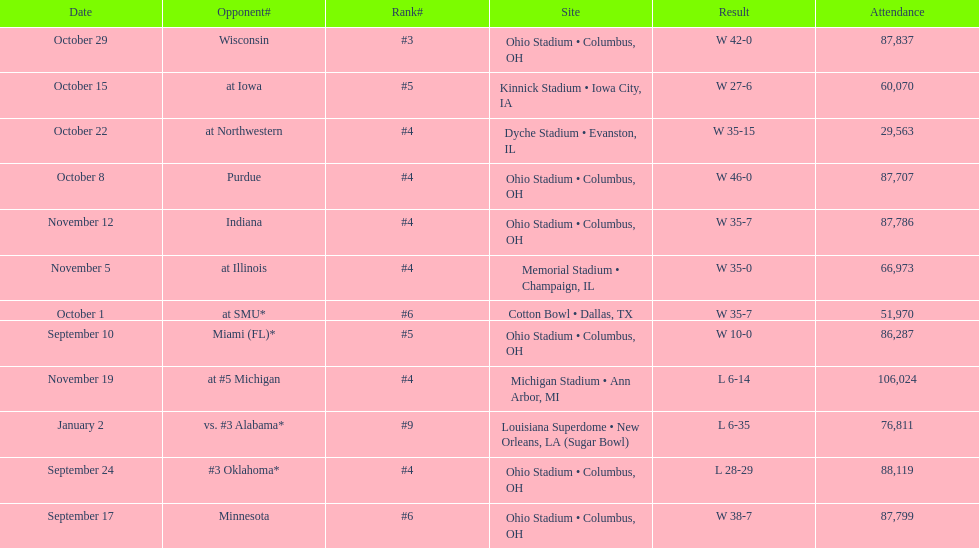What is the variance between the total of triumphs and the total of failures? 6. 